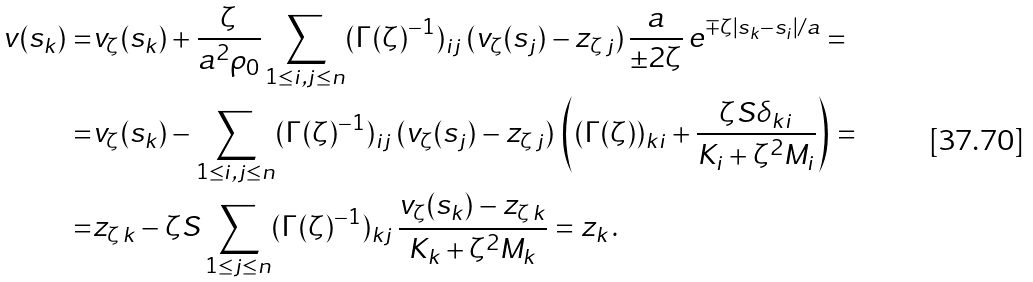<formula> <loc_0><loc_0><loc_500><loc_500>v ( s _ { k } ) = & v _ { \zeta } ( s _ { k } ) + \frac { \zeta } { a ^ { 2 } \rho _ { 0 } } \sum _ { 1 \leq i , j \leq n } ( \Gamma ( \zeta ) ^ { - 1 } ) _ { i j } \, ( v _ { \zeta } ( s _ { j } ) - z _ { \zeta \, j } ) \, \frac { a } { \pm 2 \zeta } \, e ^ { \mp \zeta | s _ { k } - s _ { i } | / a } = \\ = & v _ { \zeta } ( s _ { k } ) - \sum _ { 1 \leq i , j \leq n } ( \Gamma ( \zeta ) ^ { - 1 } ) _ { i j } \, ( v _ { \zeta } ( s _ { j } ) - z _ { \zeta \, j } ) \, \left ( ( \Gamma ( \zeta ) ) _ { k i } + \frac { \zeta S \delta _ { k i } } { K _ { i } + \zeta ^ { 2 } M _ { i } } \right ) = \\ = & z _ { \zeta \, k } - \zeta S \sum _ { 1 \leq j \leq n } ( \Gamma ( \zeta ) ^ { - 1 } ) _ { k j } \, \frac { v _ { \zeta } ( s _ { k } ) - z _ { \zeta \, k } } { K _ { k } + \zeta ^ { 2 } M _ { k } } = z _ { k } \, .</formula> 